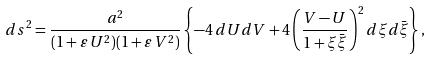<formula> <loc_0><loc_0><loc_500><loc_500>d s ^ { 2 } = \frac { a ^ { 2 } } { ( 1 + \varepsilon \, U ^ { 2 } ) ( 1 + \varepsilon \, V ^ { 2 } ) } \left \{ - 4 \, d U d V + 4 \left ( \frac { V - U } { 1 + \xi \bar { \xi } } \right ) ^ { 2 } d \xi d \bar { \xi } \right \} ,</formula> 